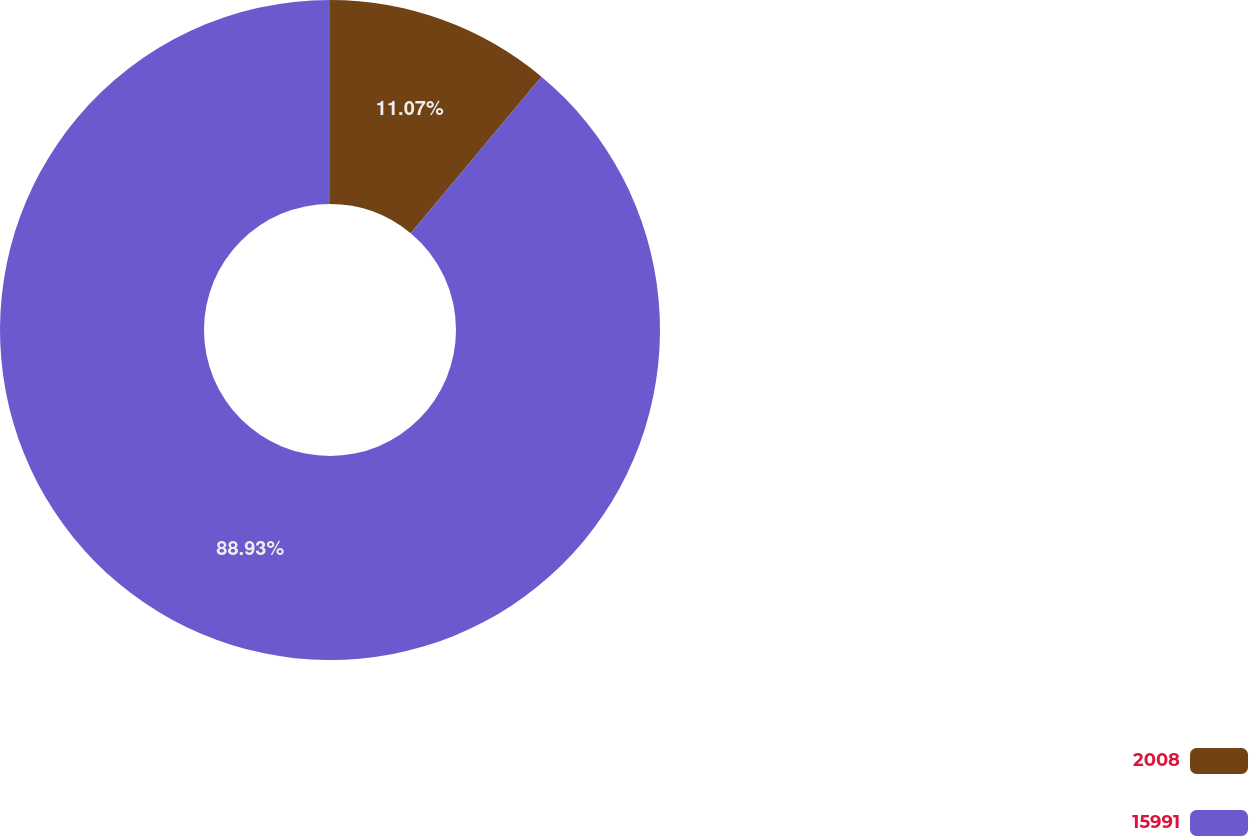<chart> <loc_0><loc_0><loc_500><loc_500><pie_chart><fcel>2008<fcel>15991<nl><fcel>11.07%<fcel>88.93%<nl></chart> 